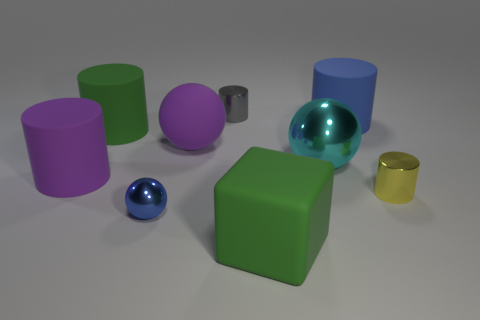The tiny thing that is in front of the small cylinder in front of the large purple ball is made of what material?
Your response must be concise. Metal. How big is the matte cylinder to the right of the small thing in front of the small metal object to the right of the tiny gray metallic thing?
Ensure brevity in your answer.  Large. What number of cyan balls are the same material as the yellow cylinder?
Your answer should be compact. 1. What is the color of the object left of the big green object that is on the left side of the blue shiny object?
Make the answer very short. Purple. What number of things are either red cylinders or things that are behind the small yellow shiny object?
Keep it short and to the point. 6. Is there a large matte object of the same color as the block?
Offer a very short reply. Yes. How many green things are small metal cylinders or balls?
Offer a terse response. 0. What number of other objects are there of the same size as the purple cylinder?
Your response must be concise. 5. What number of tiny things are rubber objects or metallic things?
Provide a short and direct response. 3. Does the gray shiny cylinder have the same size as the green thing in front of the large metallic ball?
Keep it short and to the point. No. 